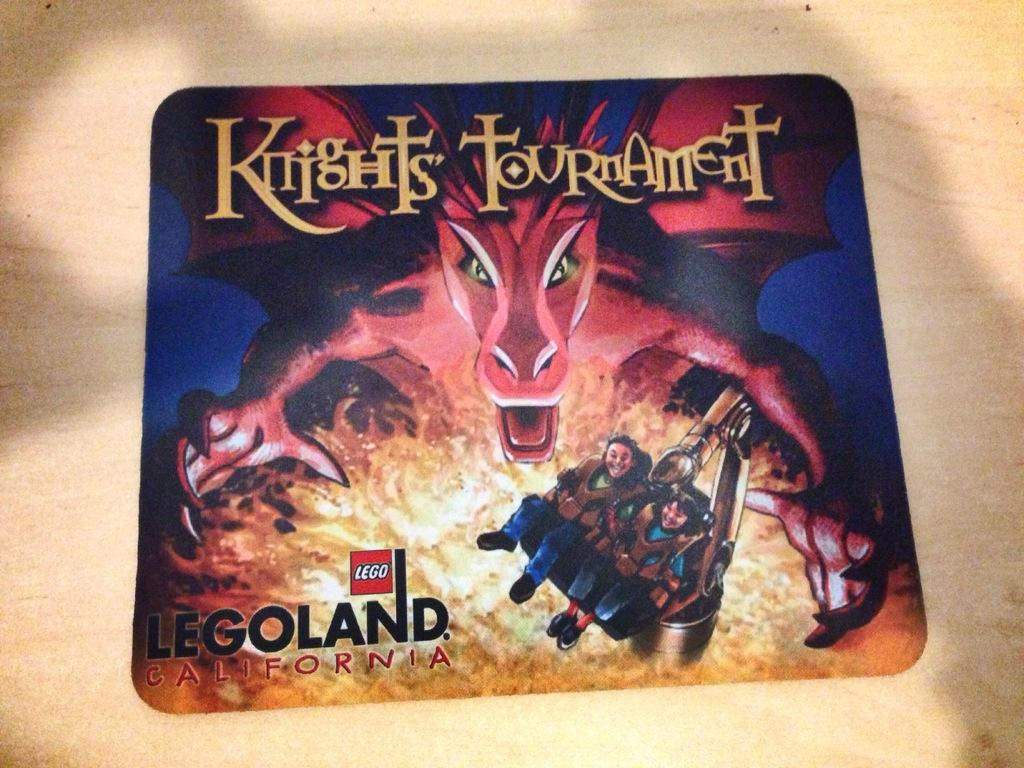What is the main object in the image? There is a table in the image. What is on the table? There is a banner on the table. What is depicted on the banner? The banner features a dragon, fire, and two people. Is there any text on the banner? Yes, there is some matter written on the banner. Can you tell me how many snakes are slithering on the table in the image? There are no snakes present in the image; the table features a banner with a dragon, fire, and two people. 